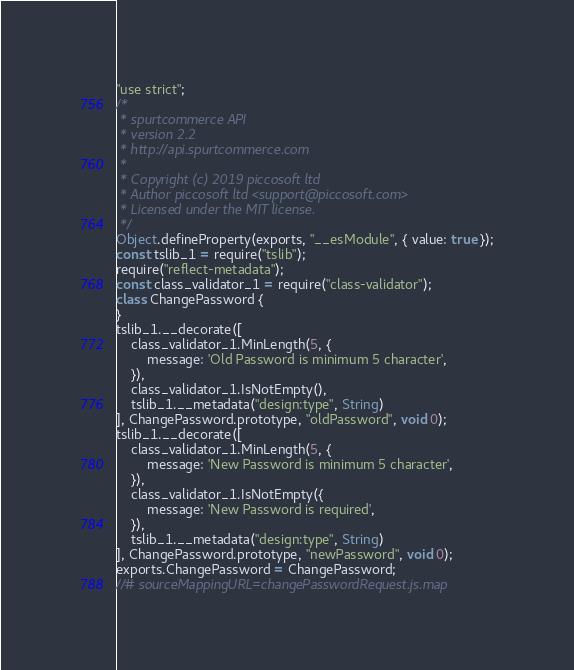Convert code to text. <code><loc_0><loc_0><loc_500><loc_500><_JavaScript_>"use strict";
/*
 * spurtcommerce API
 * version 2.2
 * http://api.spurtcommerce.com
 *
 * Copyright (c) 2019 piccosoft ltd
 * Author piccosoft ltd <support@piccosoft.com>
 * Licensed under the MIT license.
 */
Object.defineProperty(exports, "__esModule", { value: true });
const tslib_1 = require("tslib");
require("reflect-metadata");
const class_validator_1 = require("class-validator");
class ChangePassword {
}
tslib_1.__decorate([
    class_validator_1.MinLength(5, {
        message: 'Old Password is minimum 5 character',
    }),
    class_validator_1.IsNotEmpty(),
    tslib_1.__metadata("design:type", String)
], ChangePassword.prototype, "oldPassword", void 0);
tslib_1.__decorate([
    class_validator_1.MinLength(5, {
        message: 'New Password is minimum 5 character',
    }),
    class_validator_1.IsNotEmpty({
        message: 'New Password is required',
    }),
    tslib_1.__metadata("design:type", String)
], ChangePassword.prototype, "newPassword", void 0);
exports.ChangePassword = ChangePassword;
//# sourceMappingURL=changePasswordRequest.js.map</code> 